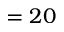<formula> <loc_0><loc_0><loc_500><loc_500>= 2 0</formula> 